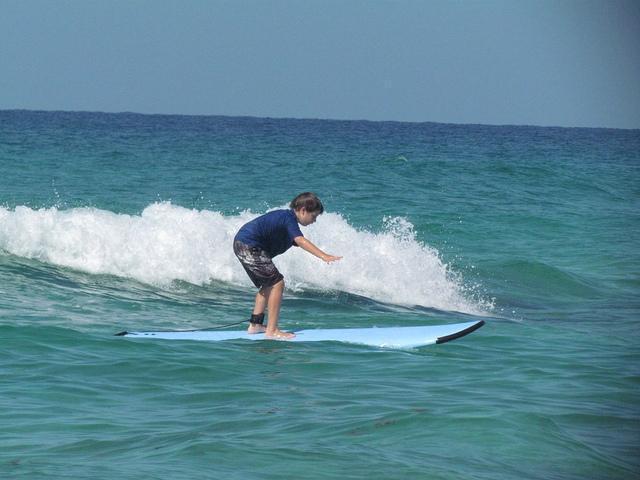How many shirts can be seen?
Give a very brief answer. 1. How many people are in the photo?
Give a very brief answer. 1. How many different colors of bears are there?
Give a very brief answer. 0. 